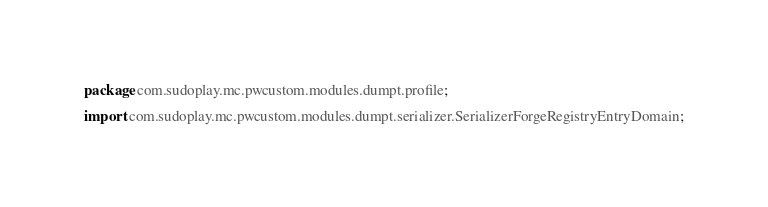<code> <loc_0><loc_0><loc_500><loc_500><_Java_>package com.sudoplay.mc.pwcustom.modules.dumpt.profile;

import com.sudoplay.mc.pwcustom.modules.dumpt.serializer.SerializerForgeRegistryEntryDomain;</code> 